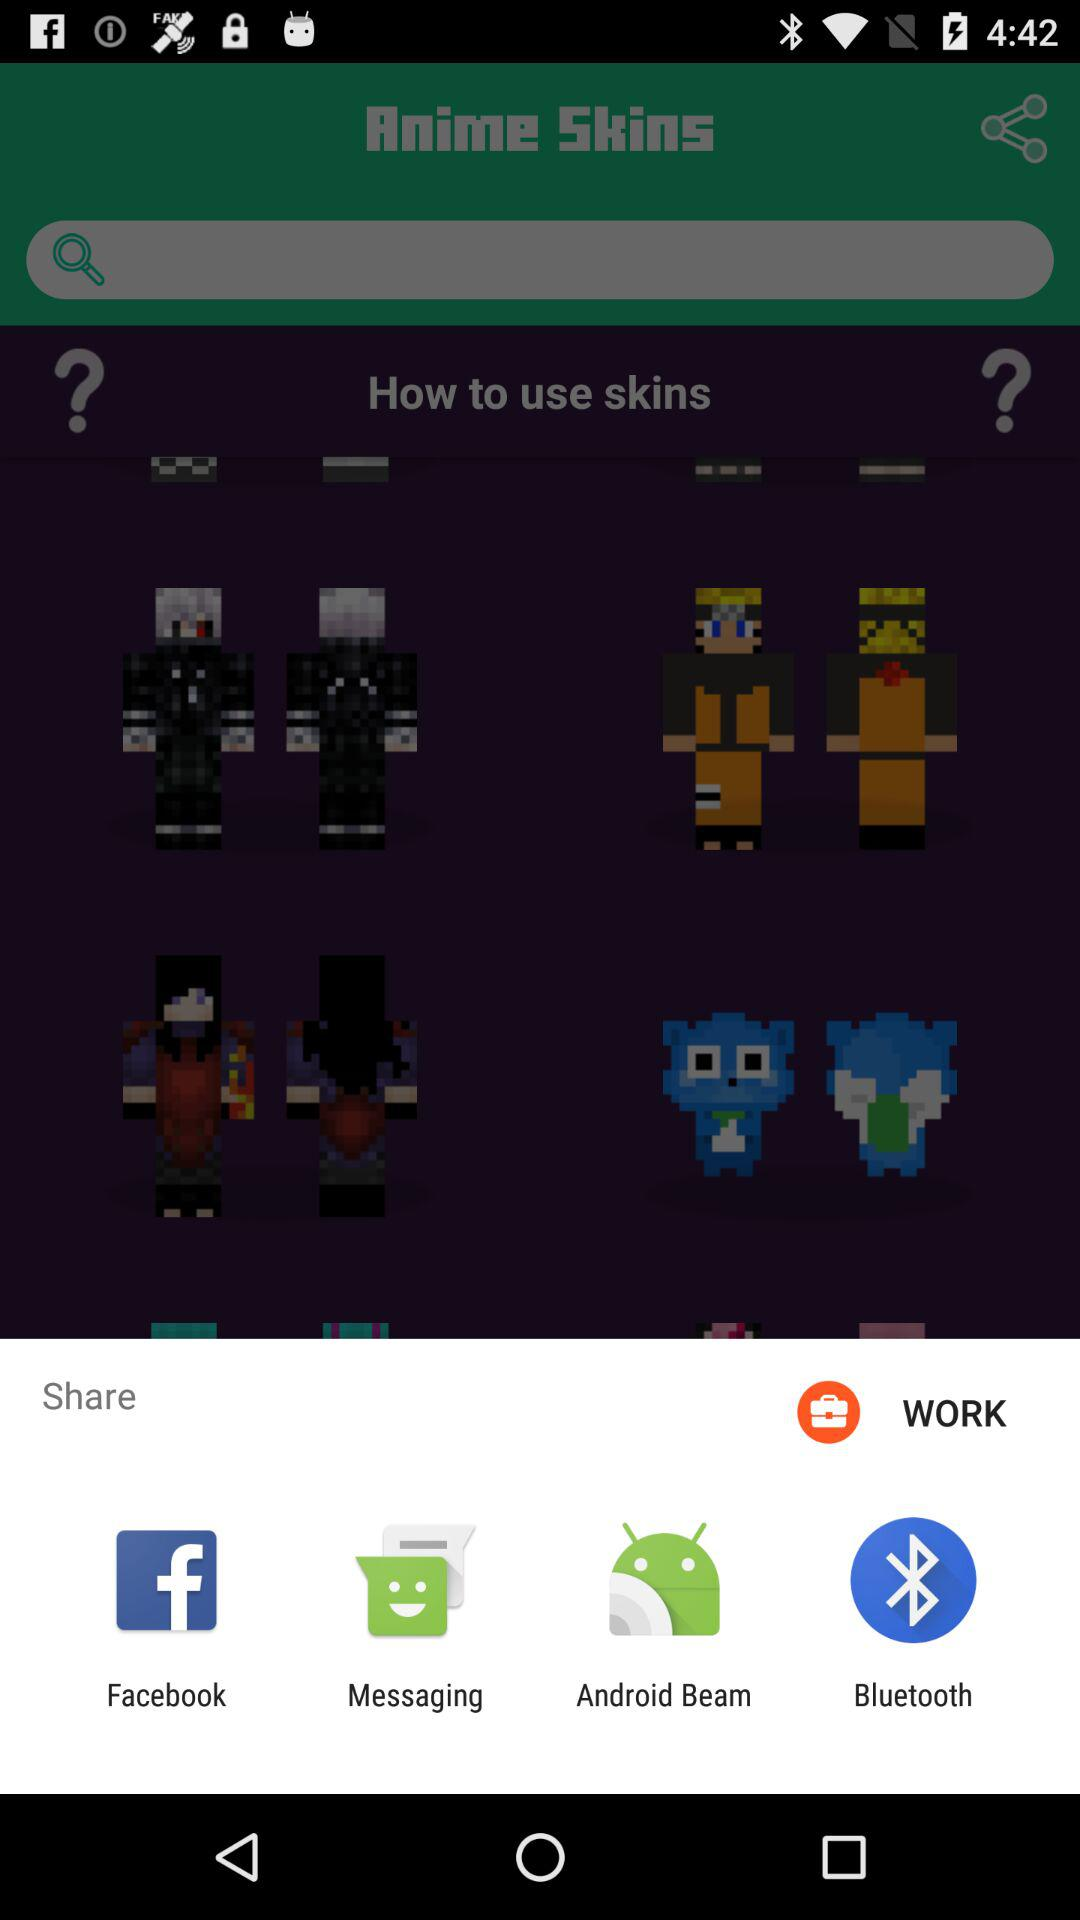What are the apps that can be used to share the content? The apps that can be used to share the content are "Facebook", "Messaging", "Android Beam" and "Bluetooth". 